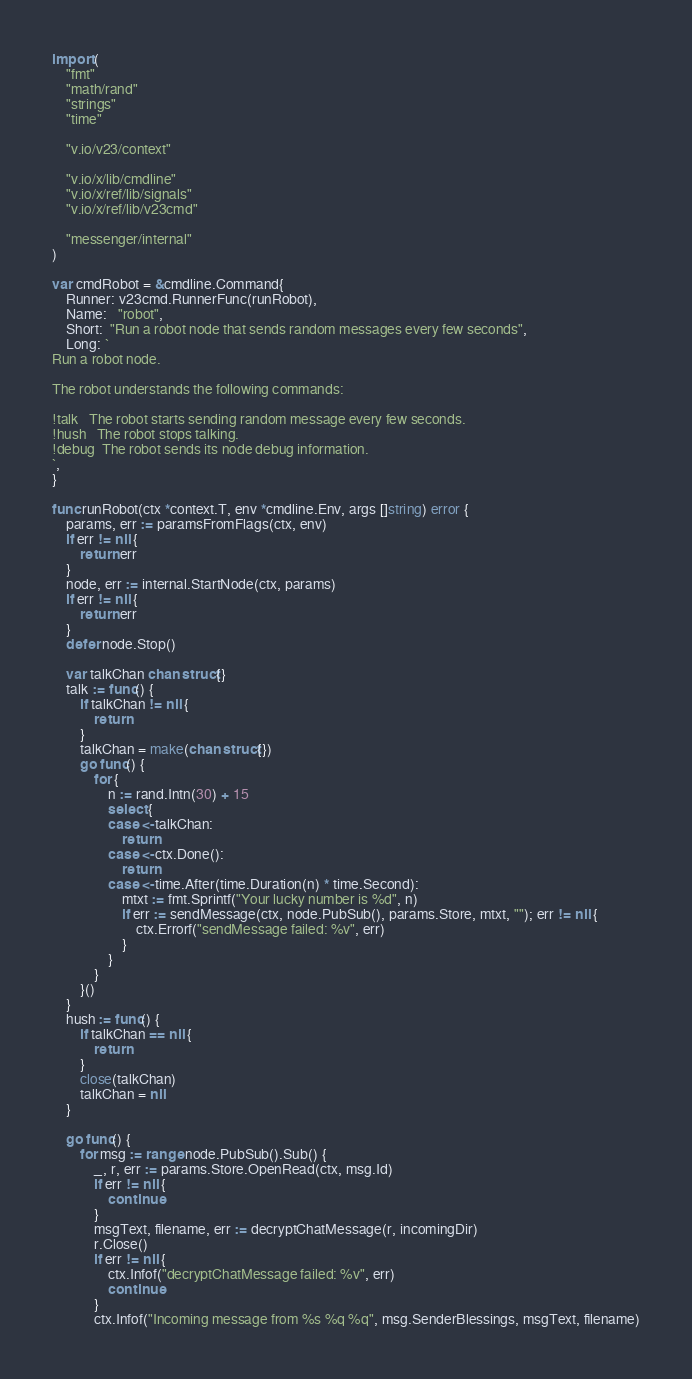<code> <loc_0><loc_0><loc_500><loc_500><_Go_>import (
	"fmt"
	"math/rand"
	"strings"
	"time"

	"v.io/v23/context"

	"v.io/x/lib/cmdline"
	"v.io/x/ref/lib/signals"
	"v.io/x/ref/lib/v23cmd"

	"messenger/internal"
)

var cmdRobot = &cmdline.Command{
	Runner: v23cmd.RunnerFunc(runRobot),
	Name:   "robot",
	Short:  "Run a robot node that sends random messages every few seconds",
	Long: `
Run a robot node.

The robot understands the following commands:

!talk   The robot starts sending random message every few seconds.
!hush   The robot stops talking.
!debug  The robot sends its node debug information.
`,
}

func runRobot(ctx *context.T, env *cmdline.Env, args []string) error {
	params, err := paramsFromFlags(ctx, env)
	if err != nil {
		return err
	}
	node, err := internal.StartNode(ctx, params)
	if err != nil {
		return err
	}
	defer node.Stop()

	var talkChan chan struct{}
	talk := func() {
		if talkChan != nil {
			return
		}
		talkChan = make(chan struct{})
		go func() {
			for {
				n := rand.Intn(30) + 15
				select {
				case <-talkChan:
					return
				case <-ctx.Done():
					return
				case <-time.After(time.Duration(n) * time.Second):
					mtxt := fmt.Sprintf("Your lucky number is %d", n)
					if err := sendMessage(ctx, node.PubSub(), params.Store, mtxt, ""); err != nil {
						ctx.Errorf("sendMessage failed: %v", err)
					}
				}
			}
		}()
	}
	hush := func() {
		if talkChan == nil {
			return
		}
		close(talkChan)
		talkChan = nil
	}

	go func() {
		for msg := range node.PubSub().Sub() {
			_, r, err := params.Store.OpenRead(ctx, msg.Id)
			if err != nil {
				continue
			}
			msgText, filename, err := decryptChatMessage(r, incomingDir)
			r.Close()
			if err != nil {
				ctx.Infof("decryptChatMessage failed: %v", err)
				continue
			}
			ctx.Infof("Incoming message from %s %q %q", msg.SenderBlessings, msgText, filename)</code> 